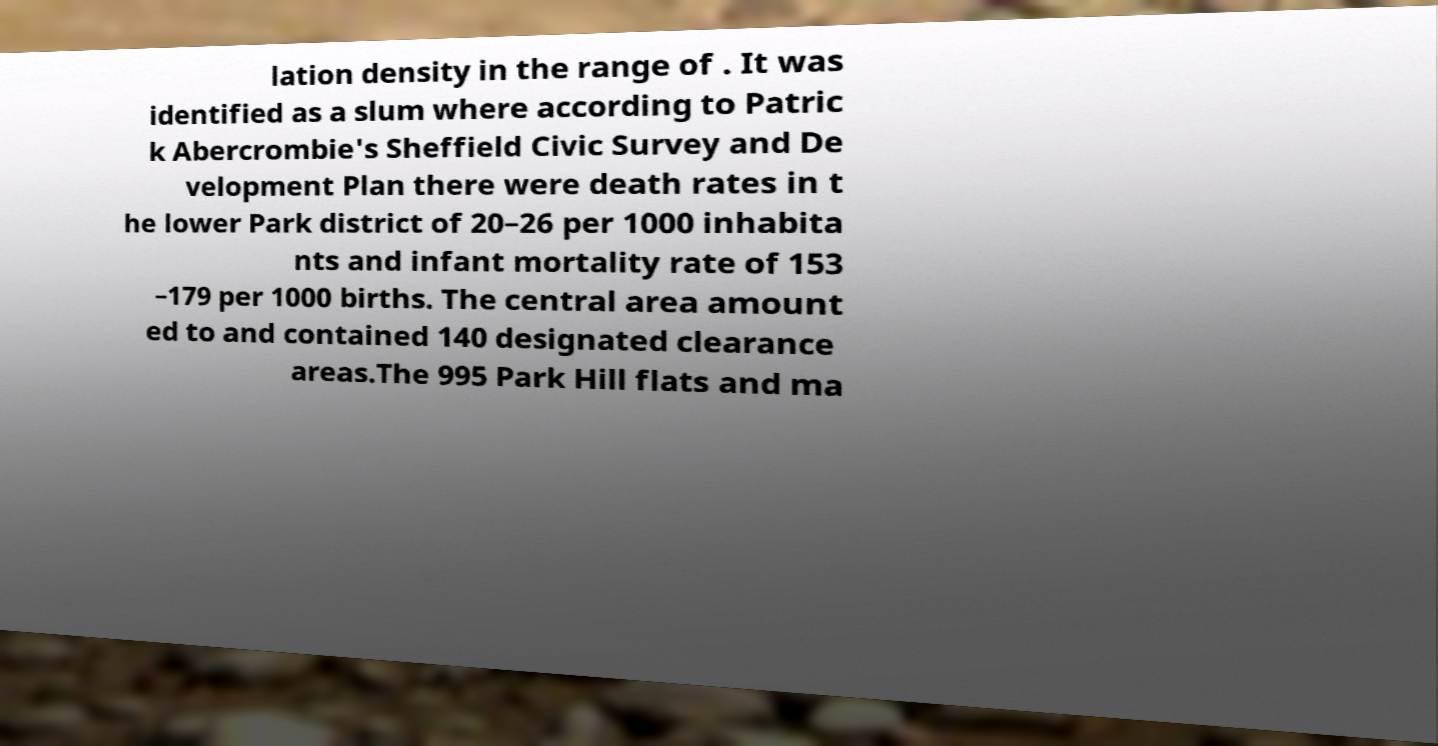For documentation purposes, I need the text within this image transcribed. Could you provide that? lation density in the range of . It was identified as a slum where according to Patric k Abercrombie's Sheffield Civic Survey and De velopment Plan there were death rates in t he lower Park district of 20–26 per 1000 inhabita nts and infant mortality rate of 153 –179 per 1000 births. The central area amount ed to and contained 140 designated clearance areas.The 995 Park Hill flats and ma 